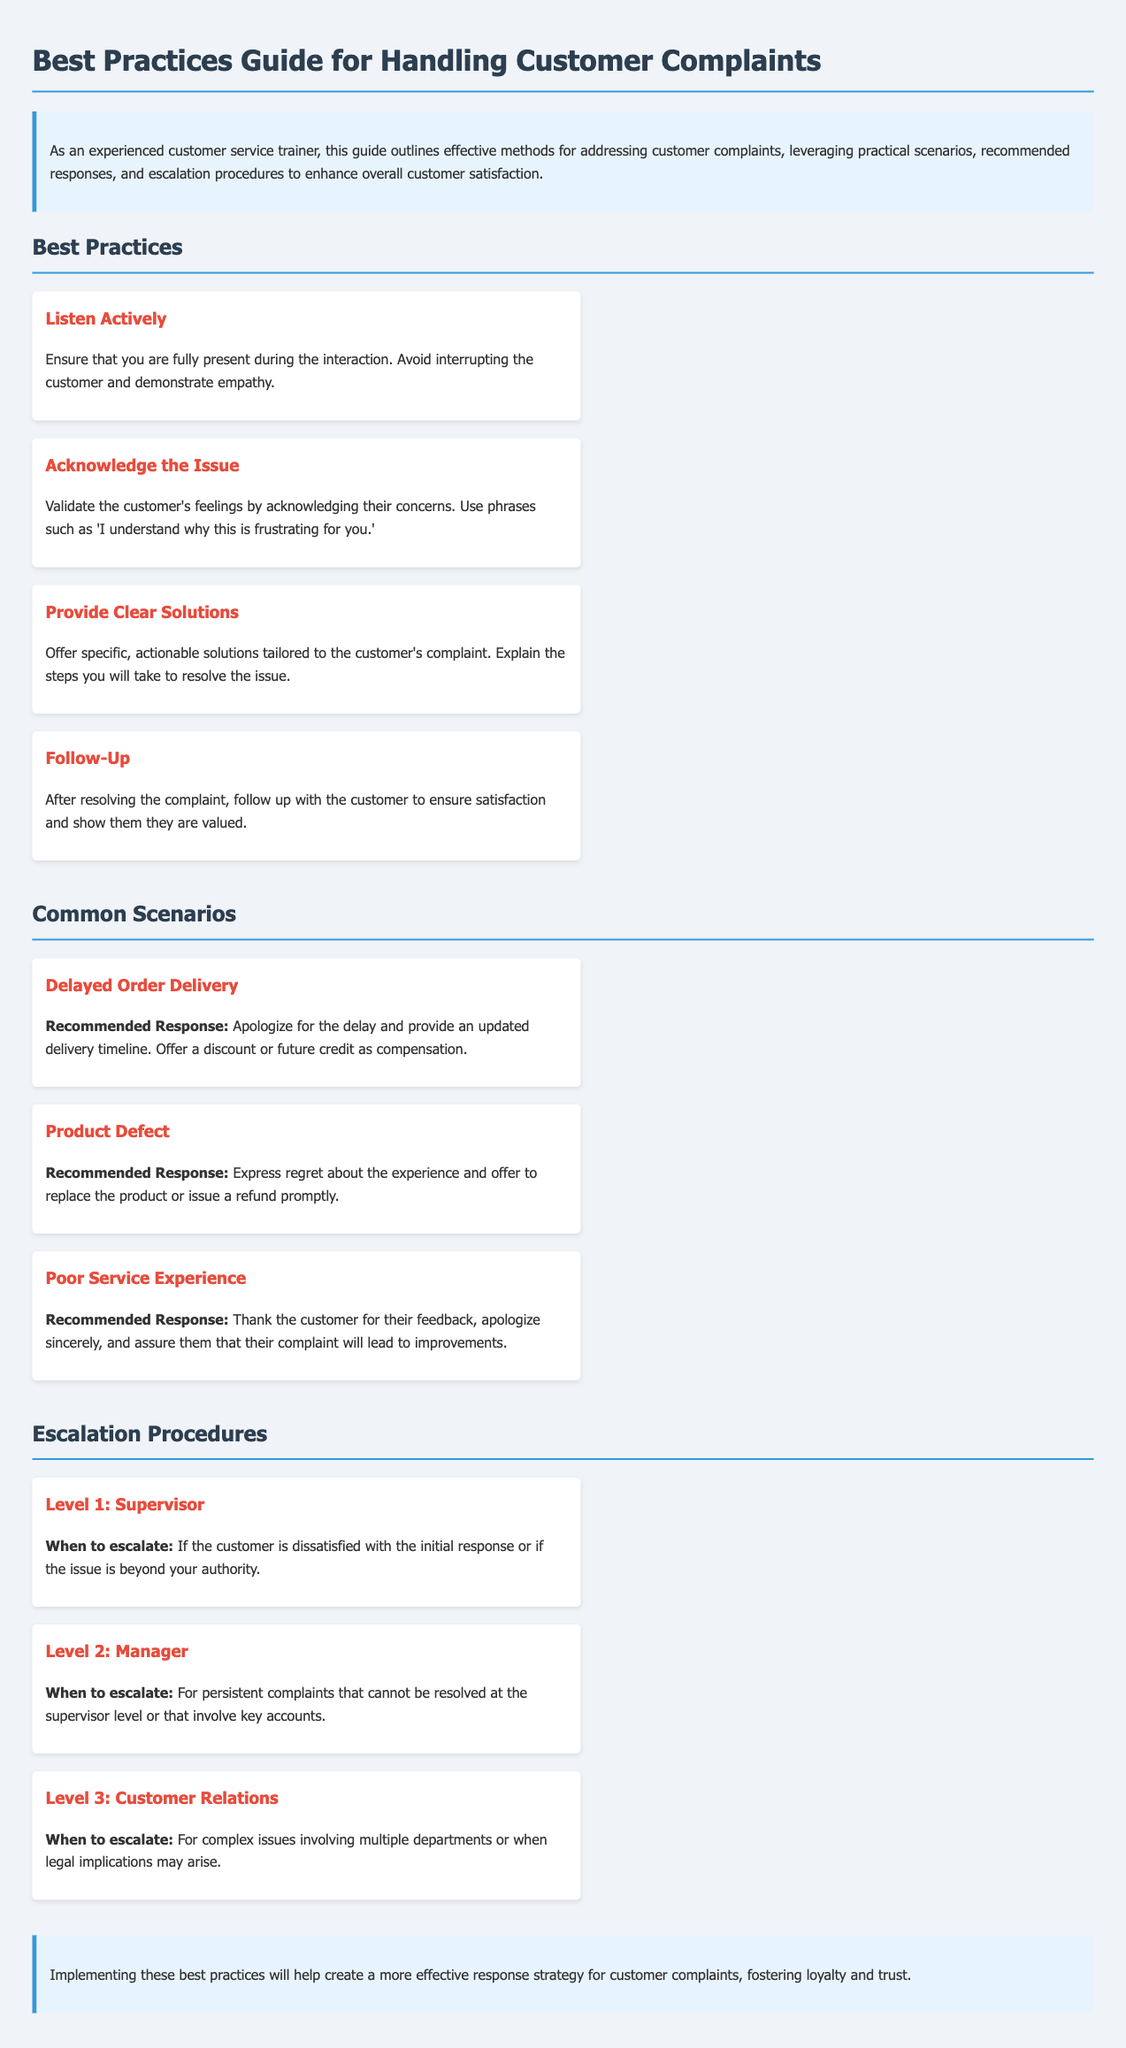What are the best practices listed? The document outlines best practices for handling customer complaints. These include Listen Actively, Acknowledge the Issue, Provide Clear Solutions, and Follow-Up.
Answer: Listen Actively, Acknowledge the Issue, Provide Clear Solutions, Follow-Up What should be done for a delayed order delivery? The recommended response for a delayed order delivery includes apologizing for the delay, providing an updated delivery timeline, and offering compensation.
Answer: Apologize, provide timeline, offer compensation How many escalation levels are there? The document specifies three escalation levels that are outlined for handling complaints.
Answer: Three What action should be taken at Level 2 escalation? At Level 2 escalation, the issue should be escalated to a manager for persistent complaints that cannot be resolved at the supervisor level.
Answer: Escalate to manager What emotion should be expressed for a product defect? Expressing regret is the recommended emotional response for handling a complaint regarding a product defect.
Answer: Regret What is the purpose of following up with the customer? Following up with the customer ensures their satisfaction and shows that they are valued after the complaint is resolved.
Answer: Ensure satisfaction, show they are valued When should an issue be escalated to Level 3? An issue should be escalated to Level 3 when it involves complex problems with multiple departments or potential legal implications.
Answer: Complex issues, legal implications What type of training does this guide focus on? This guide focuses on training related to handling customer complaints effectively in customer service.
Answer: Customer service training 